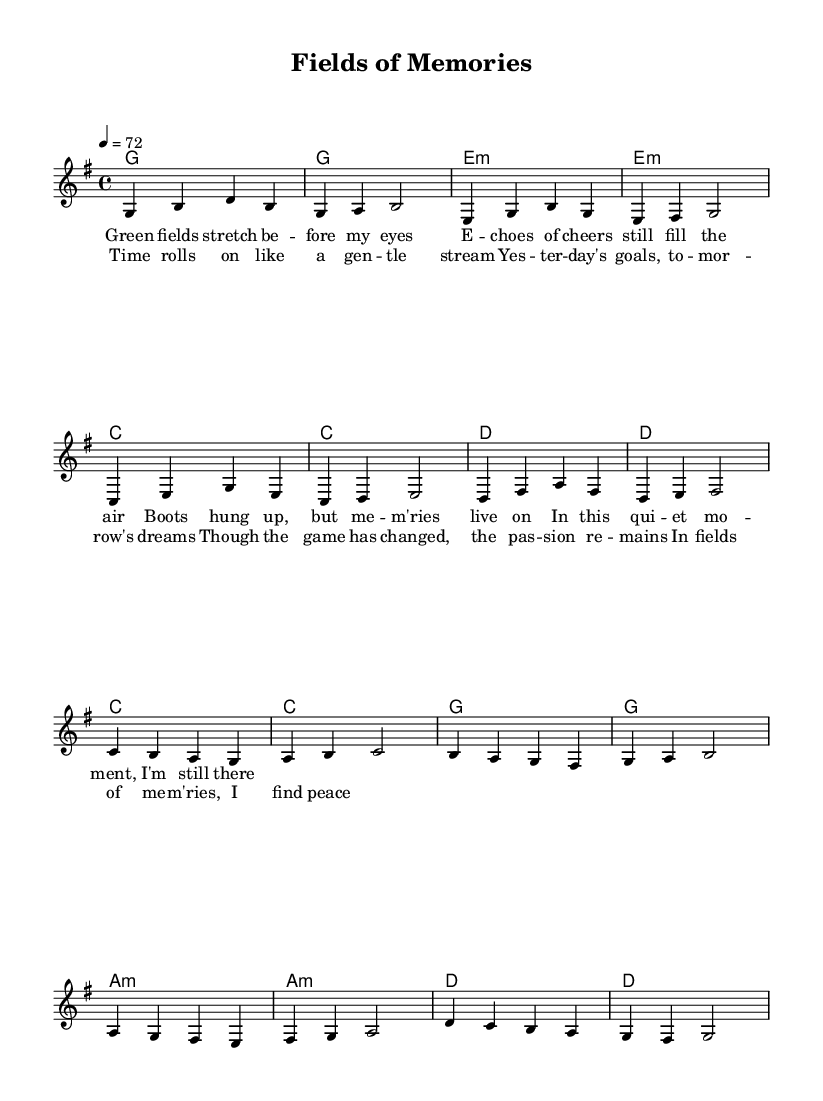What is the key signature of this music? The key signature is G major, which has one sharp (F#). This can be identified at the beginning of the sheet music where the key signature is indicated.
Answer: G major What is the time signature of this piece? The time signature is indicated as 4/4 at the beginning of the score. This means there are four beats in each measure and the quarter note gets one beat.
Answer: 4/4 What is the tempo marking for this piece? The tempo marking is given as 4 = 72, which means there are 72 beats per minute, and the quarter note is chosen as the originating note for the tempo.
Answer: 72 How many measures are in the verse section? The verse consists of 8 measures, which can be counted in the melody section where the notes are organized into 8 distinct groupings separated by vertical bar lines.
Answer: 8 Which chord follows the E minor chord in the verse? The chord following the E minor chord (e:m) in the verse is a C major chord, as indicated in the harmonies section where the chords are sequenced.
Answer: C What is the primary theme of the chorus lyrics? The primary theme revolves around the passage of time and reflections on past experiences in the context of memories from playing soccer, emphasizing that, despite change, the passion remains. This can be discerned from the lyrical content of the chorus.
Answer: Reflection on time How many different chord types are used in this piece? There are three different types of chords used in this piece: major chords, minor chords, and one diminished chord (not explicitly mentioned but can be inferred by the context of common chords). These can be identified in the harmonies portion of the score.
Answer: Three 